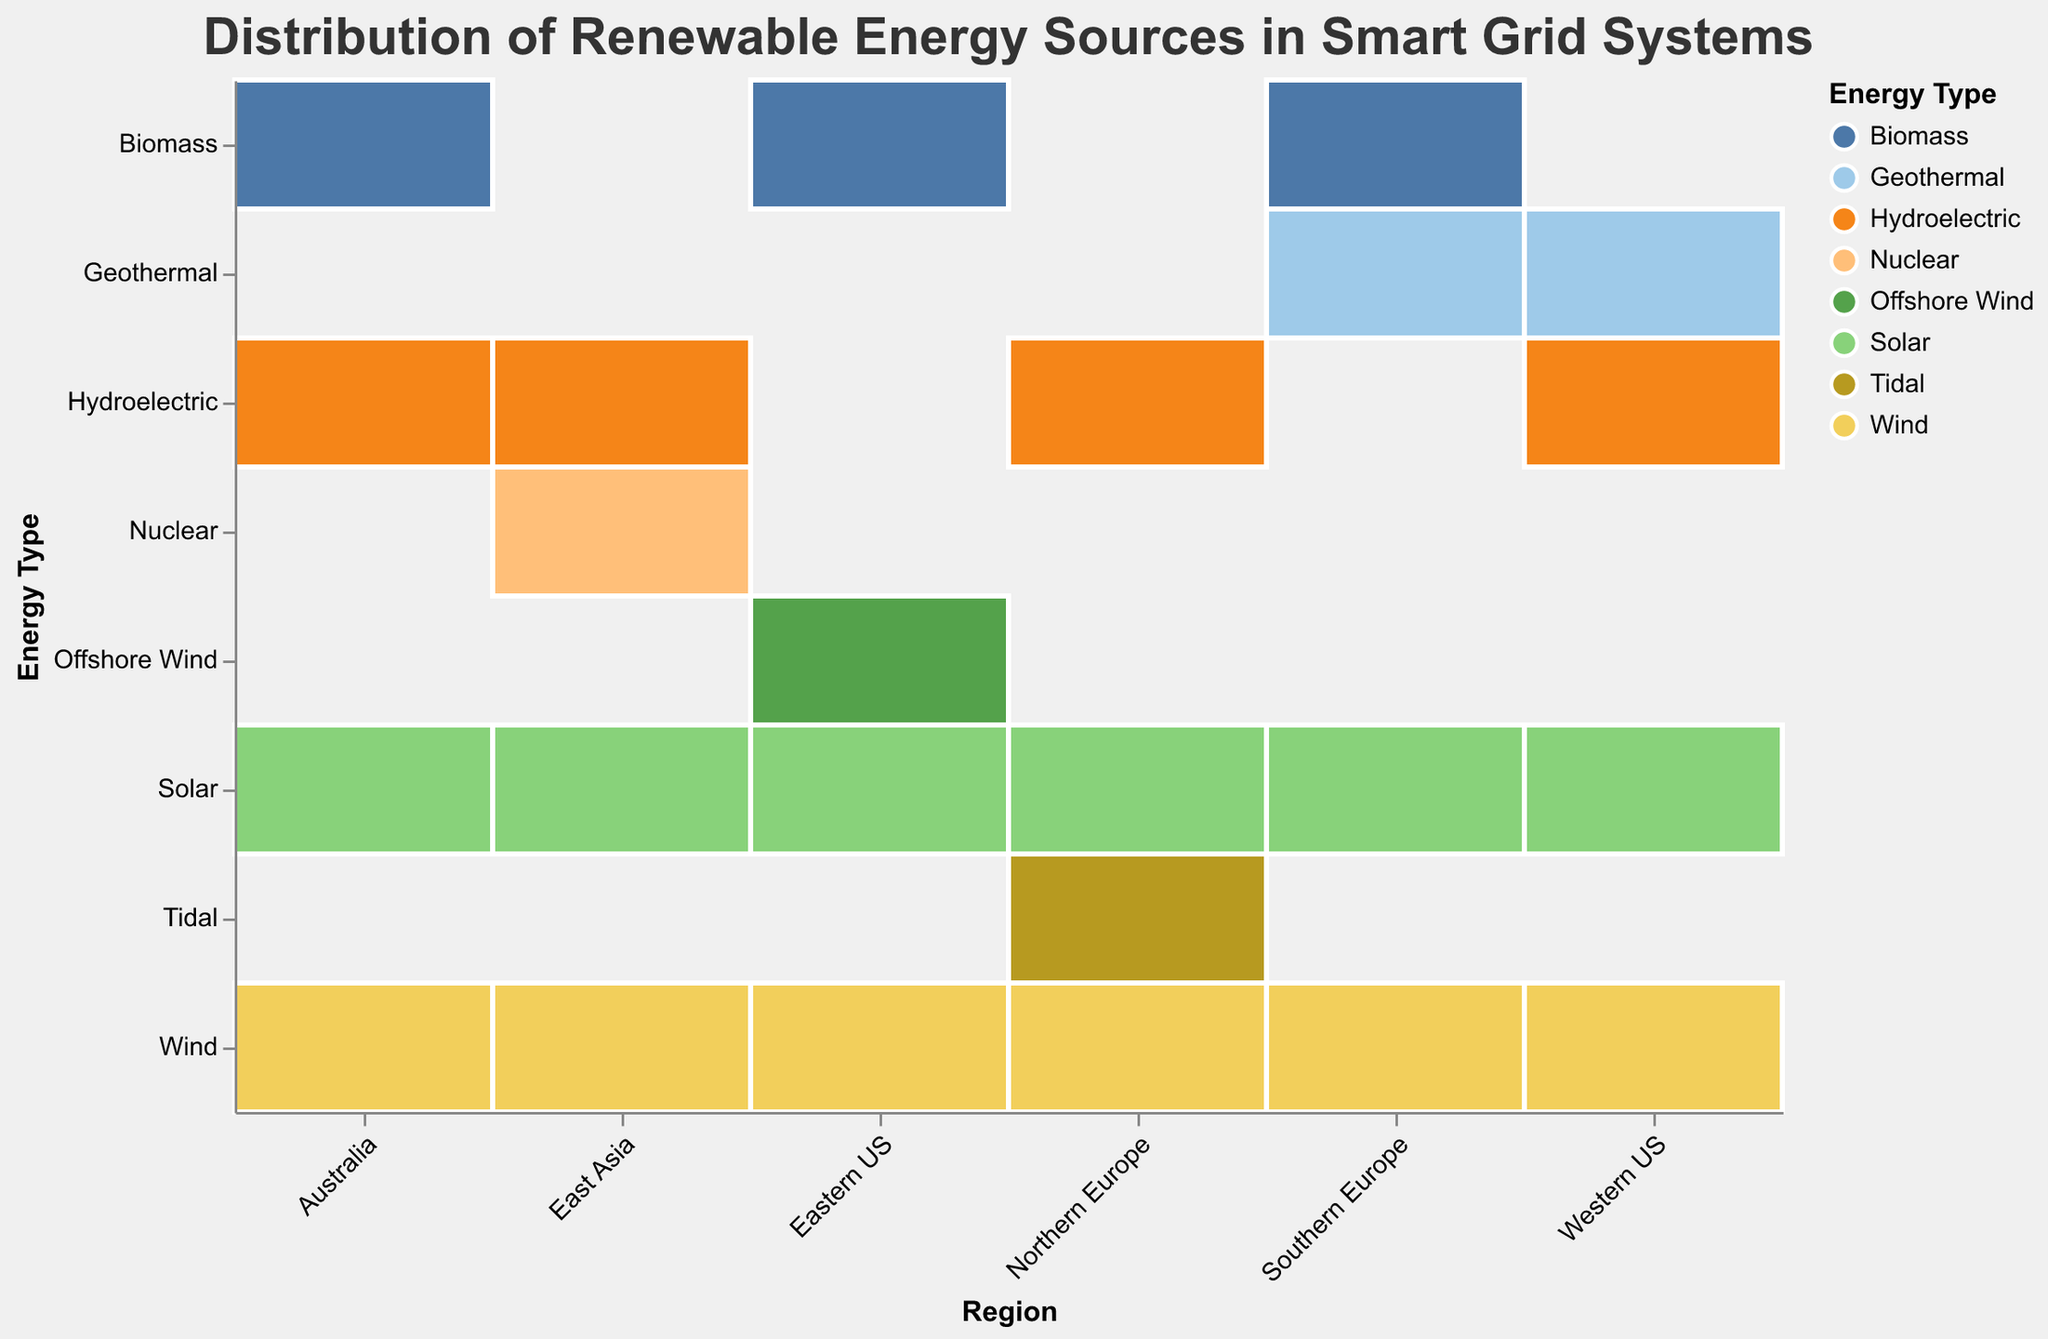Which region has the highest percentage of solar energy? Look at the "Solar" row and identify the highest percentage across all regions. Australia shows the highest value with 55%.
Answer: Australia Which energy type contributes the most in Northern Europe? Look at the "Northern Europe" column and identify the maximum percentage. Wind energy has the highest percentage of 45%.
Answer: Wind Calculate the total percentage of biomass energy in the Eastern US and Australia. Look at the "Biomass" row for Eastern US and Australia and sum the percentages: 15% (Eastern US) + 5% (Australia) = 20%.
Answer: 20% Which region utilizes geothermal energy and at what percentage? Identify the regions that have "Geothermal" in the "Energy Type" column and list their percentages. Western US (10%) and Southern Europe (5%).
Answer: Western US (10%), Southern Europe (5%) What is the difference between the percentage of wind energy in Western US and Eastern US? Look at the "Wind" row for Western US and Eastern US, then subtract the two percentages: 40% (Eastern US) - 25% (Western US) = 15%.
Answer: 15% Which energy type has the lowest percentage in East Asia? In the "East Asia" column, identify the energy type with the lowest percentage. Nuclear energy has the lowest percentage at 5%.
Answer: Nuclear Compare the percentages of hydroelectric energy in Northern Europe and Australia. Which is higher? Look at the "Hydroelectric" row for Northern Europe and Australia. Northern Europe has 25%, and Australia has 10%. Thus, Northern Europe has the higher percentage.
Answer: Northern Europe What is the average percentage of solar energy across all regions? Add up all percentages for "Solar" across all regions: 35% + 30% + 20% + 50% + 40% + 55% = 230%. Then, divide by the number of regions (6): 230% / 6 ≈ 38.33%.
Answer: 38.33% In which region is offshore wind energy used? Identify the region with "Offshore Wind" in the "Energy Type" column. It is only used in the Eastern US.
Answer: Eastern US What energy types are used exclusively in Northern Europe and what are their percentages? Identify the unique energy types in Northern Europe column. Tidal energy at 5%.
Answer: Tidal (5%) 